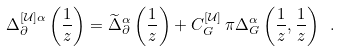<formula> <loc_0><loc_0><loc_500><loc_500>\Delta ^ { [ \mathcal { U } ] \alpha } _ { \partial } \left ( \frac { 1 } { z } \right ) = \widetilde { \Delta } _ { \partial } ^ { \alpha } \left ( \frac { 1 } { z } \right ) + C _ { G } ^ { [ \mathcal { U } ] } \, \pi \Delta _ { G } ^ { \alpha } \left ( \frac { 1 } { z } , \frac { 1 } { z } \right ) \ .</formula> 